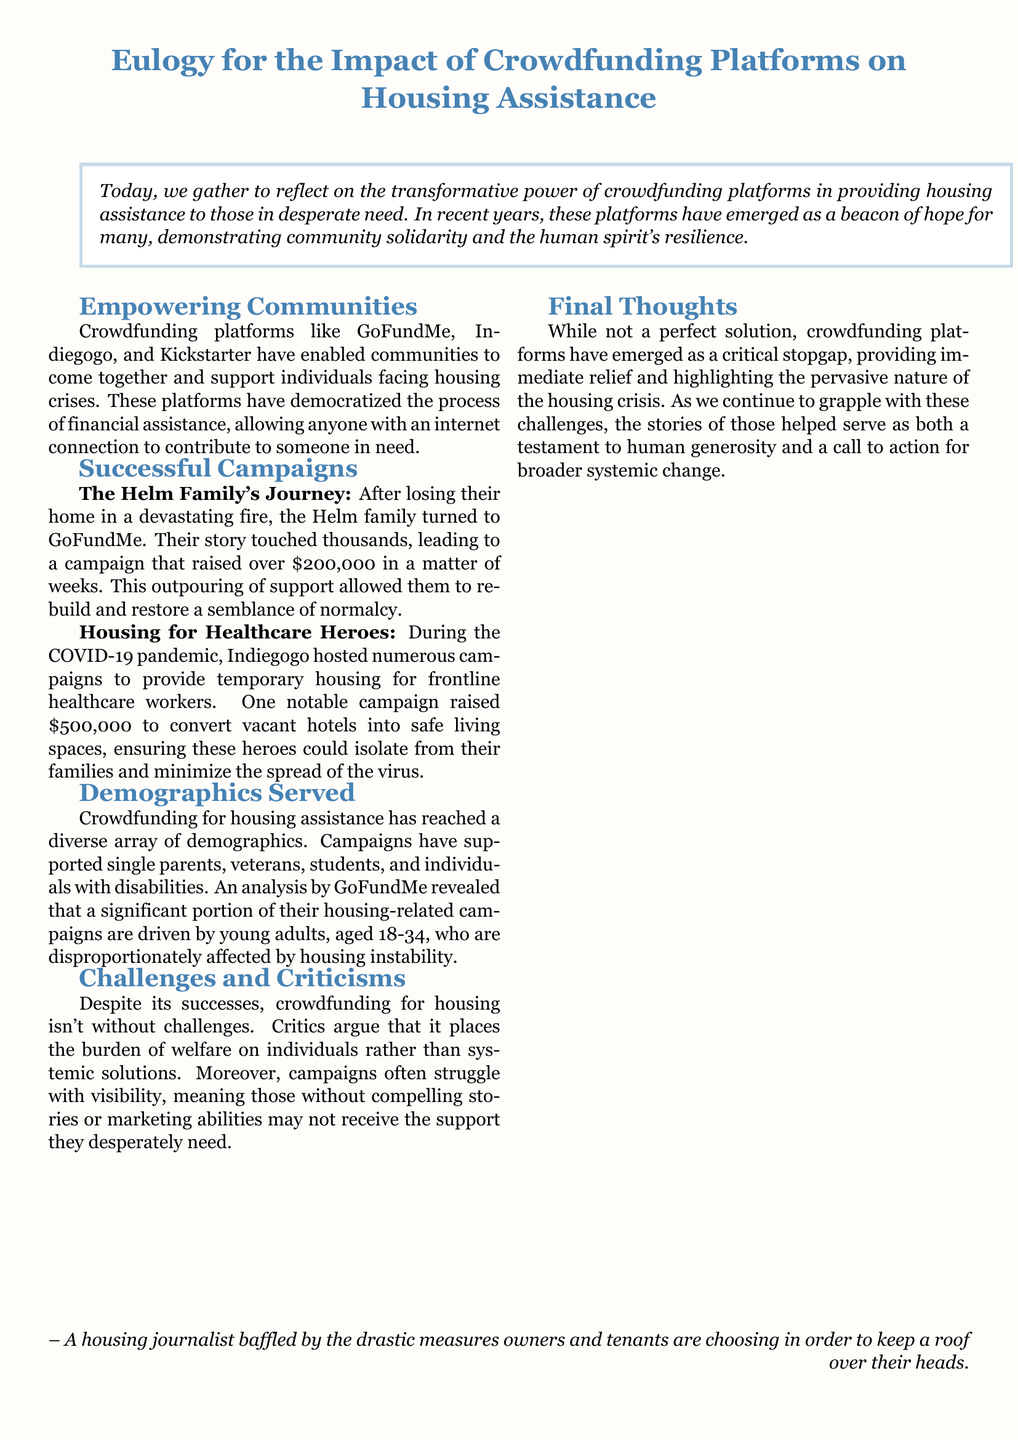What crowdfunding platform did the Helm family use? The document mentions that the Helm family turned to GoFundMe for their housing assistance.
Answer: GoFundMe How much did the Helm family raise through their crowdfunding campaign? The document states that the Helm family raised over $200,000 in their campaign.
Answer: $200,000 What was the main purpose of the campaign during the COVID-19 pandemic? The document highlights that the purpose was to provide temporary housing for frontline healthcare workers.
Answer: Temporary housing Which crowdfunding platform raised $500,000 for healthcare heroes? The document clearly indicates that Indiegogo hosted the campaign that raised $500,000.
Answer: Indiegogo What demographic is primarily affected by housing instability according to GoFundMe? The document states that young adults, aged 18-34, are disproportionately affected by housing instability.
Answer: Young adults What kind of support did crowdfunding platforms provide according to the document? The document describes crowdfunding platforms as providing immediate relief to those in need.
Answer: Immediate relief What criticism is mentioned in relation to crowdfunding for housing? The document notes that critics argue it puts the burden of welfare on individuals rather than systemic solutions.
Answer: Individual burden What does the eulogy call for regarding the housing crisis? The document concludes that the stories of those helped serve as a call to action for broader systemic change.
Answer: Broader systemic change 